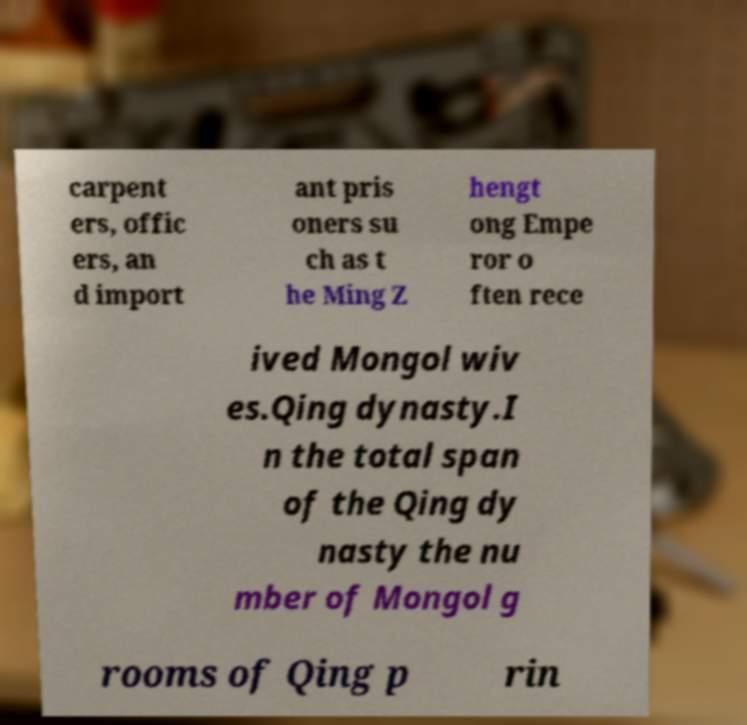Please identify and transcribe the text found in this image. carpent ers, offic ers, an d import ant pris oners su ch as t he Ming Z hengt ong Empe ror o ften rece ived Mongol wiv es.Qing dynasty.I n the total span of the Qing dy nasty the nu mber of Mongol g rooms of Qing p rin 